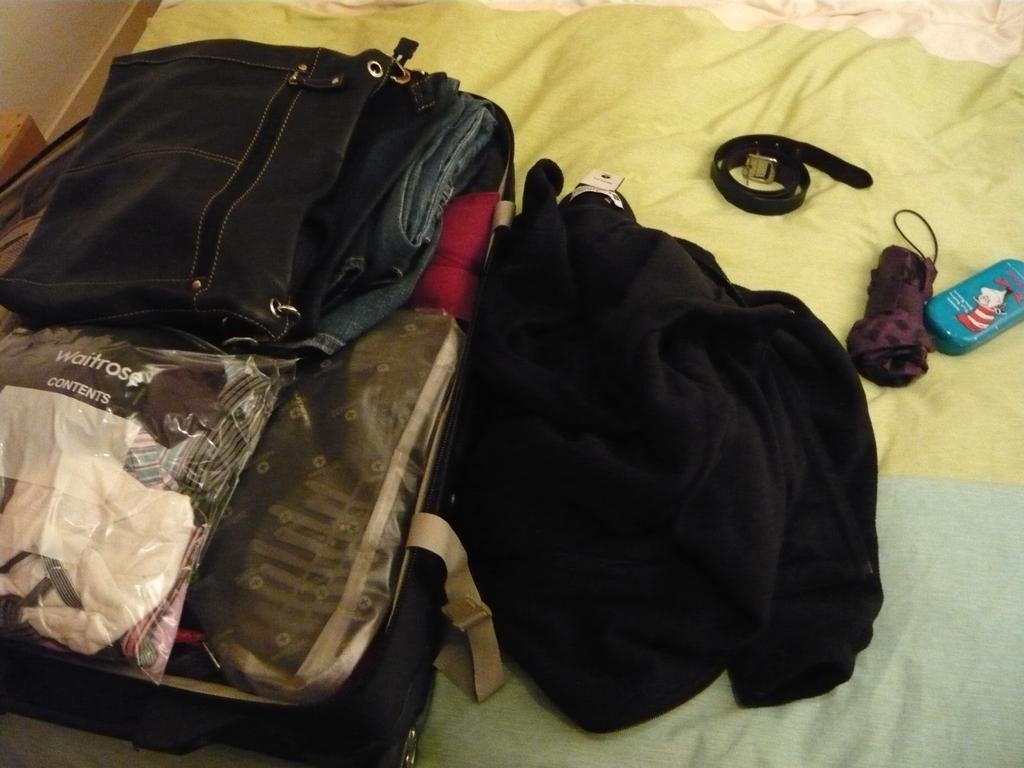What type of animal is in the image? There is a bird in the image. How is the bird positioned in the image? The bird is covered with a cloth and on a bed. What other items can be seen in the image? There is a skate cloth, a box, and an umbrella in the image. How does the bird sort the items on the bed in the image? The bird does not sort any items in the image; it is covered with a cloth and not interacting with any objects. 